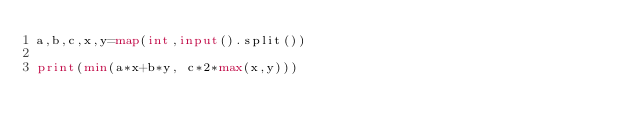Convert code to text. <code><loc_0><loc_0><loc_500><loc_500><_Python_>a,b,c,x,y=map(int,input().split())

print(min(a*x+b*y, c*2*max(x,y)))</code> 